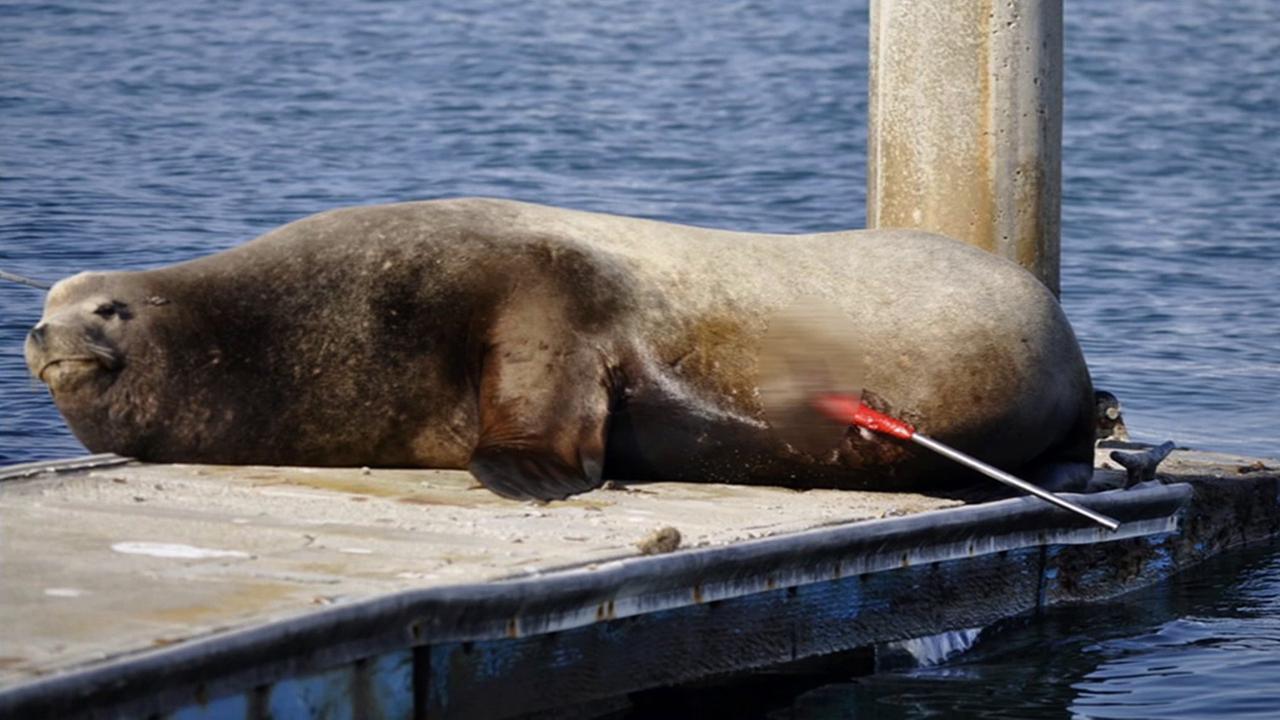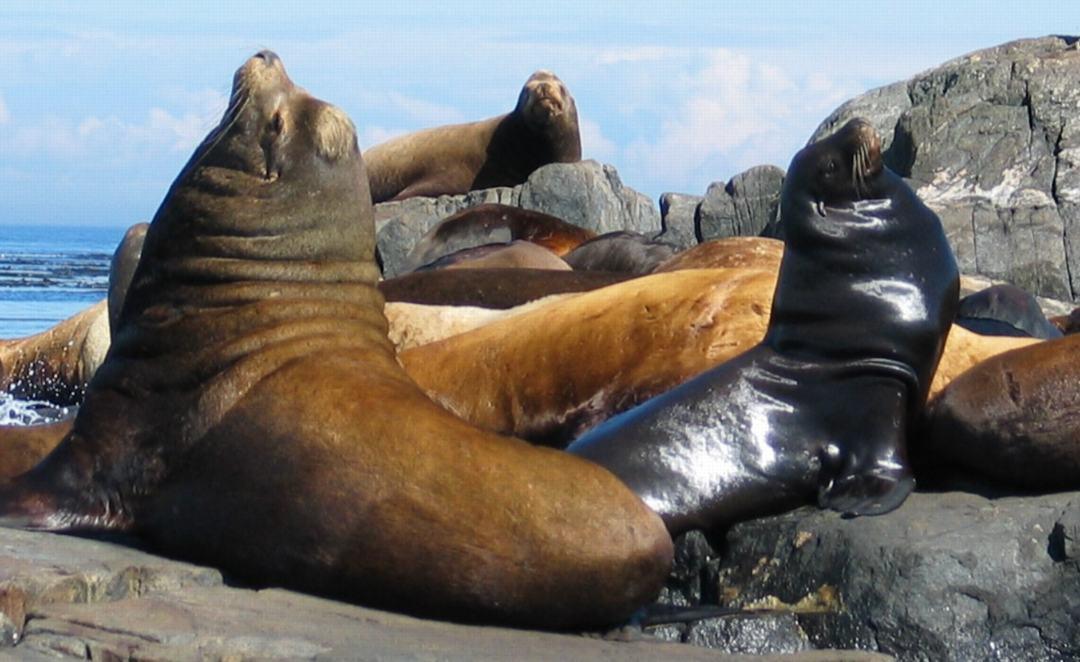The first image is the image on the left, the second image is the image on the right. For the images displayed, is the sentence "One of the sea animals is lying on a wharf near the water." factually correct? Answer yes or no. Yes. 